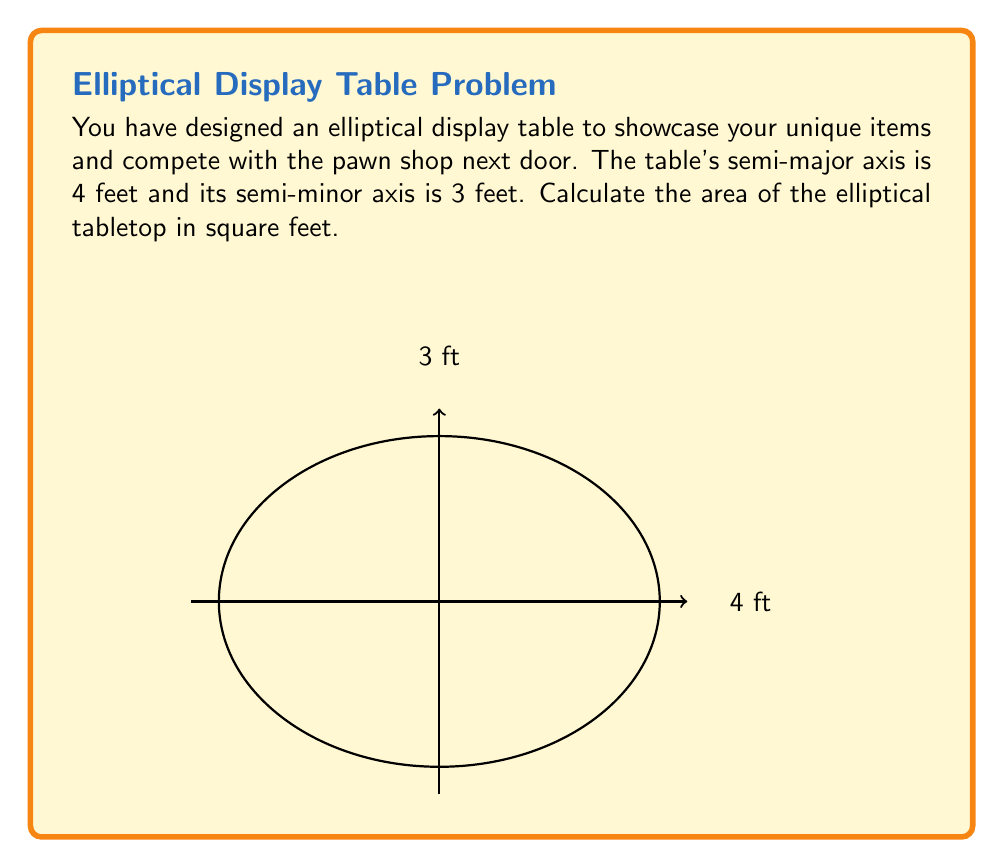Provide a solution to this math problem. To calculate the area of an ellipse, we use the formula:

$$A = \pi ab$$

Where:
$A$ is the area
$a$ is the length of the semi-major axis
$b$ is the length of the semi-minor axis
$\pi$ is approximately 3.14159

Given:
$a = 4$ feet (semi-major axis)
$b = 3$ feet (semi-minor axis)

Let's substitute these values into the formula:

$$A = \pi \cdot 4 \cdot 3$$

Now, let's calculate:

$$A = 3.14159 \cdot 4 \cdot 3$$
$$A = 3.14159 \cdot 12$$
$$A = 37.69908$$

Rounding to two decimal places:

$$A \approx 37.70 \text{ square feet}$$

Therefore, the area of your elliptical display table is approximately 37.70 square feet.
Answer: $37.70 \text{ ft}^2$ 